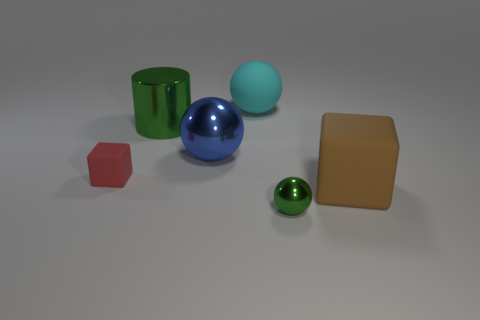There is a green metal object that is the same size as the blue thing; what shape is it?
Provide a short and direct response. Cylinder. There is a metallic sphere that is left of the big cyan thing; what is its color?
Provide a short and direct response. Blue. There is a rubber cube to the right of the big blue shiny ball; is there a large green metallic cylinder that is in front of it?
Ensure brevity in your answer.  No. How many objects are either spheres that are behind the tiny ball or blue things?
Provide a succinct answer. 2. The ball behind the big green metal object on the left side of the big cyan ball is made of what material?
Your answer should be very brief. Rubber. Are there an equal number of big brown blocks in front of the tiny metallic thing and red matte things that are behind the big blue shiny sphere?
Provide a short and direct response. Yes. What number of objects are blocks right of the large cylinder or objects that are right of the cyan matte thing?
Your answer should be very brief. 2. There is a large object that is in front of the green cylinder and behind the tiny red thing; what material is it?
Your answer should be compact. Metal. There is a rubber block that is right of the large metallic object behind the metal ball that is left of the large cyan object; how big is it?
Give a very brief answer. Large. Are there more large matte cylinders than matte cubes?
Your response must be concise. No. 